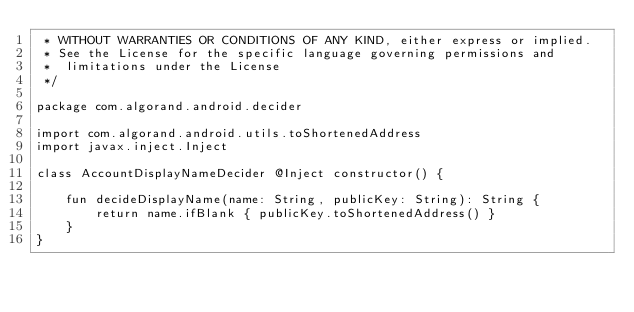Convert code to text. <code><loc_0><loc_0><loc_500><loc_500><_Kotlin_> * WITHOUT WARRANTIES OR CONDITIONS OF ANY KIND, either express or implied.
 * See the License for the specific language governing permissions and
 *  limitations under the License
 */

package com.algorand.android.decider

import com.algorand.android.utils.toShortenedAddress
import javax.inject.Inject

class AccountDisplayNameDecider @Inject constructor() {

    fun decideDisplayName(name: String, publicKey: String): String {
        return name.ifBlank { publicKey.toShortenedAddress() }
    }
}
</code> 